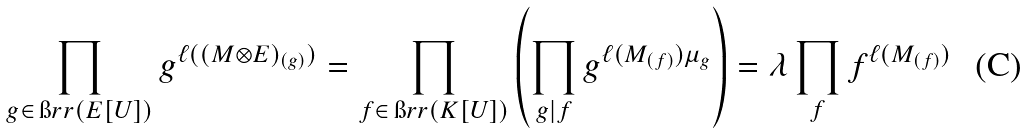<formula> <loc_0><loc_0><loc_500><loc_500>\prod _ { g \in \, \i r r ( E [ U ] ) } g ^ { \ell ( ( M \otimes E ) _ { ( g ) } ) } = \prod _ { f \in \, \i r r ( K [ U ] ) } \left ( \prod _ { g | f } g ^ { \ell ( M _ { ( f ) } ) \mu _ { g } } \right ) = \lambda \prod _ { f } f ^ { \ell ( M _ { ( f ) } ) }</formula> 